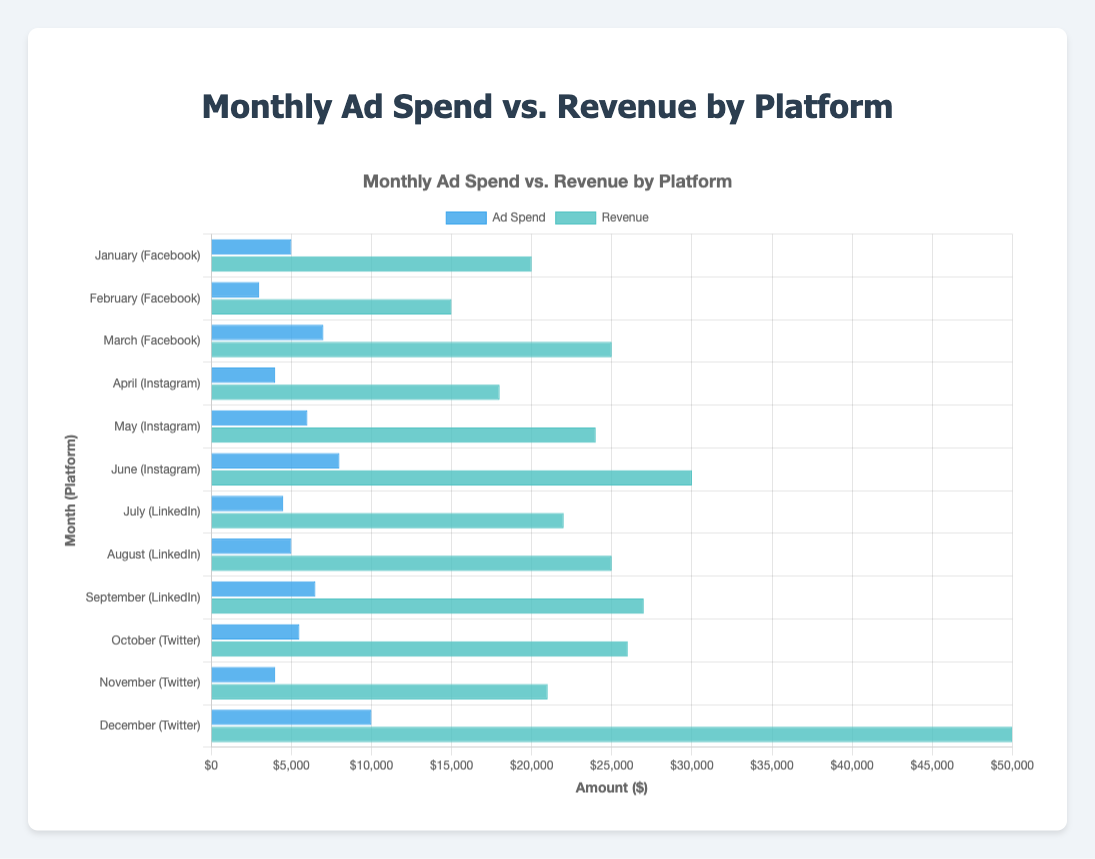What's the total ad spend across all months and platforms? To find the total ad spend, sum the ad spends for each month: 5000 + 3000 + 7000 + 4000 + 6000 + 8000 + 4500 + 5000 + 6500 + 5500 + 4000 + 10000 = 73500
Answer: 73500 Which month had the highest revenue, and what was the revenue amount? Look at the heights of the revenue bars to determine the month with the highest revenue. December's bar is the longest, indicating the highest revenue, which is $50,000.
Answer: December, 50000 What is the difference in revenue between the month with the highest ad spend and the month with the lowest ad spend? The month with the highest ad spend is December ($10,000), and the lowest is February ($3,000). The difference in revenue between these months is $50,000 (December) - $15,000 (February) = $35,000
Answer: 35000 What is the average monthly ad spend for Instagram? To find the average ad spend for Instagram, sum the ad spend for Instagram months and divide by the number of months: (4000 + 6000 + 8000) / 3 = 18000 / 3 = 6000
Answer: 6000 How much revenue was generated per dollar of ad spend in May (Instagram)? Divide the revenue by the ad spend for May: 24000 / 6000 = 4
Answer: 4 Which platform had the most consistent ad spend across the months, and what indicates this consistency visually? Visually compare the lengths of the ad spend bars for each platform. LinkedIn's ad spend bars appear closer in length, indicating more consistency.
Answer: LinkedIn 